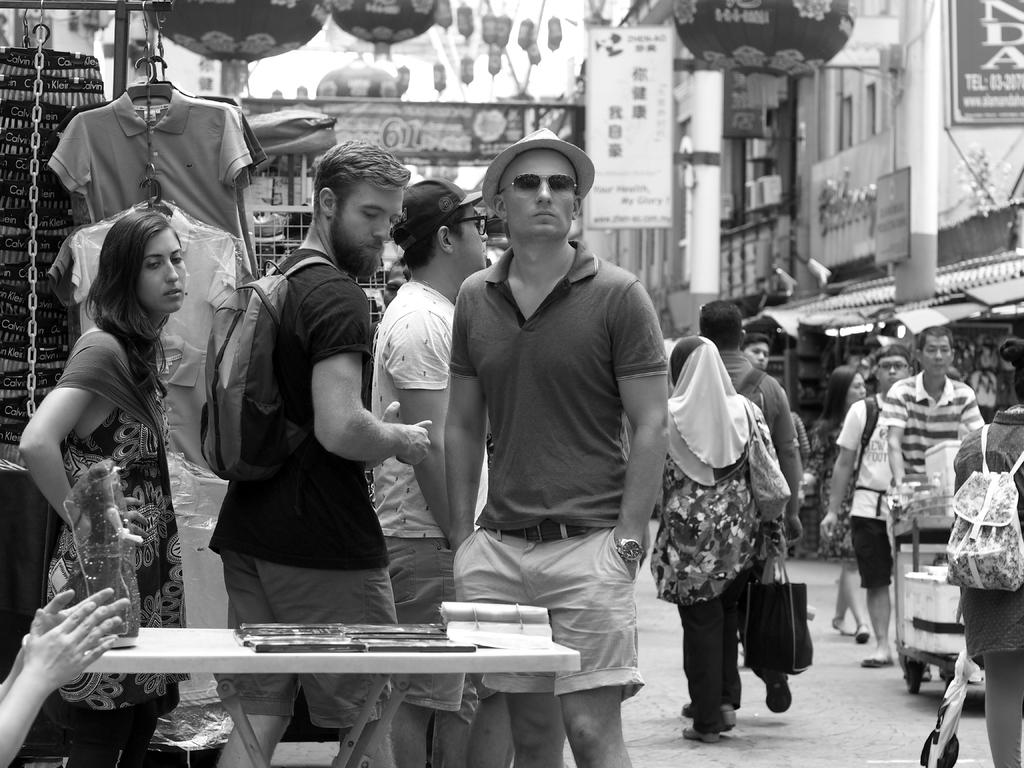Who or what can be seen in the image? There are people in the image. What type of location is depicted in the image? The location appears to be a marketplace. What can be found on both sides of the image? There are stalls on both the right and left sides of the image. What is located in the center of the image? There are posters in the center of the image. What type of beast can be seen roaming around the marketplace in the image? There is no beast present in the image; it depicts a marketplace with people and stalls. 